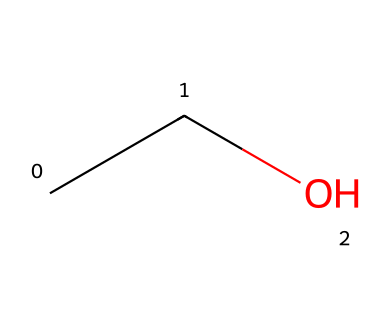What is the name of this compound? The SMILES representation "CCO" indicates the presence of two carbon atoms ("CC") and one oxygen atom ("O"). This corresponds to the structure of ethanol, commonly used as a fuel additive.
Answer: ethanol How many carbon atoms are present in the structure? By analyzing the SMILES "CCO," we note the "CC" segment indicates there are two carbon atoms present in this chemical structure.
Answer: 2 What is the primary functional group in this compound? The presence of the -OH (hydroxyl) group can be inferred from the "O" in the SMILES, which identifies ethanol as an alcohol. The -OH group is characteristic of alcohols.
Answer: hydroxyl How many hydrogen atoms are likely bonded to the carbon atoms? Ethanol (C2H5OH) will have a total of six hydrogen atoms, as each carbon typically forms four bonds, and the structure yields two carbon atoms each with three hydrogens (C2H5) plus one from the hydroxyl (-OH).
Answer: 6 What type of chemical interaction can ethanol participate in due to its functional group? The hydroxyl (-OH) group indicates that ethanol can participate in hydrogen bonding, which affects its physical properties such as boiling point and solubility.
Answer: hydrogen bonding Is this compound considered a polar or nonpolar molecule? The presence of the -OH group contributes to a significant dipole moment due to its electronegativity, thus making ethanol a polar molecule overall.
Answer: polar 